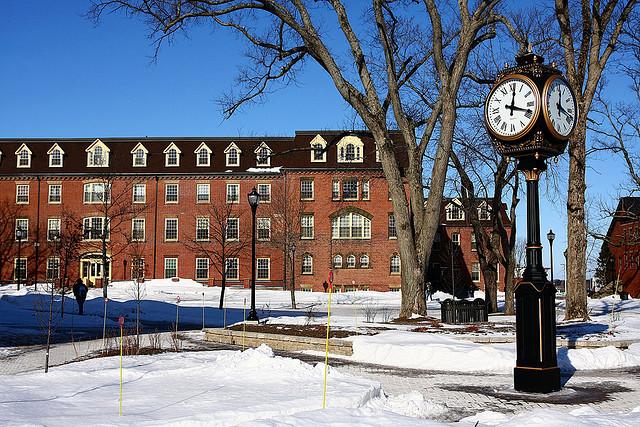What this picture was taken?
Answer briefly. Winter. What time is on the clock?
Quick response, please. 12:18. Is it Winter time?
Keep it brief. Yes. 